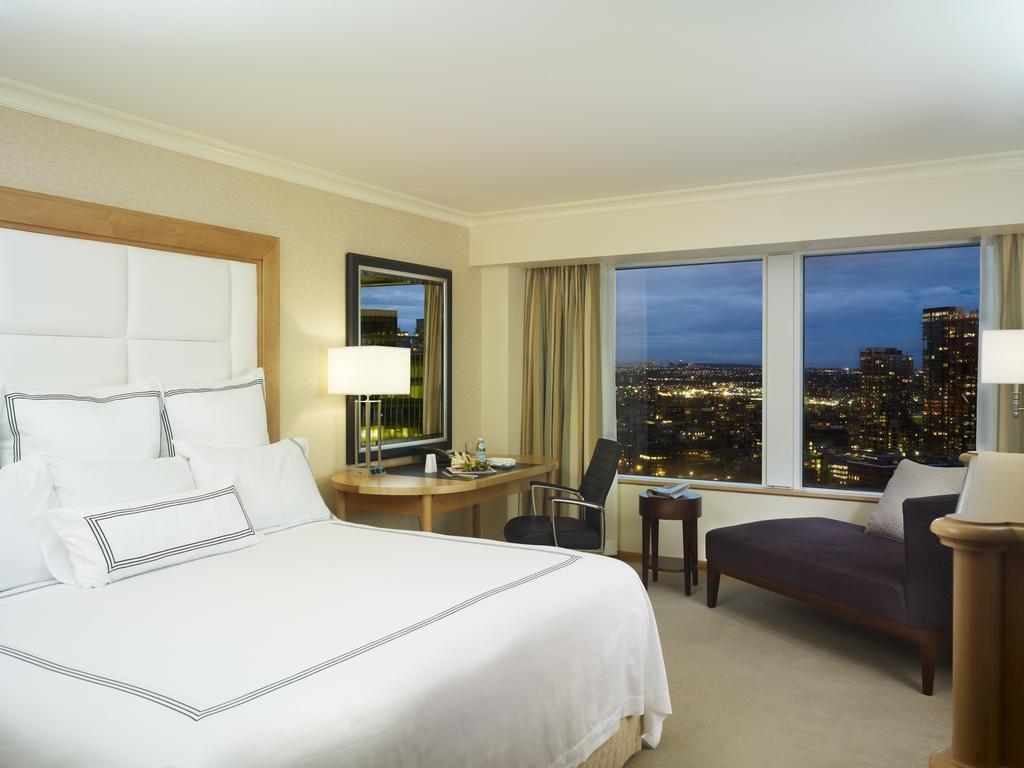In one or two sentences, can you explain what this image depicts? As we can see in the image, there is a bed. On bed there is a white color bed sheet and white color pillows. Beside the bed there is a table. On table there is a bottle, plate and lamp. In front of table there is a mirror and beside the table there is a window and cream color curtain, a chair and the floor is in cream color. 